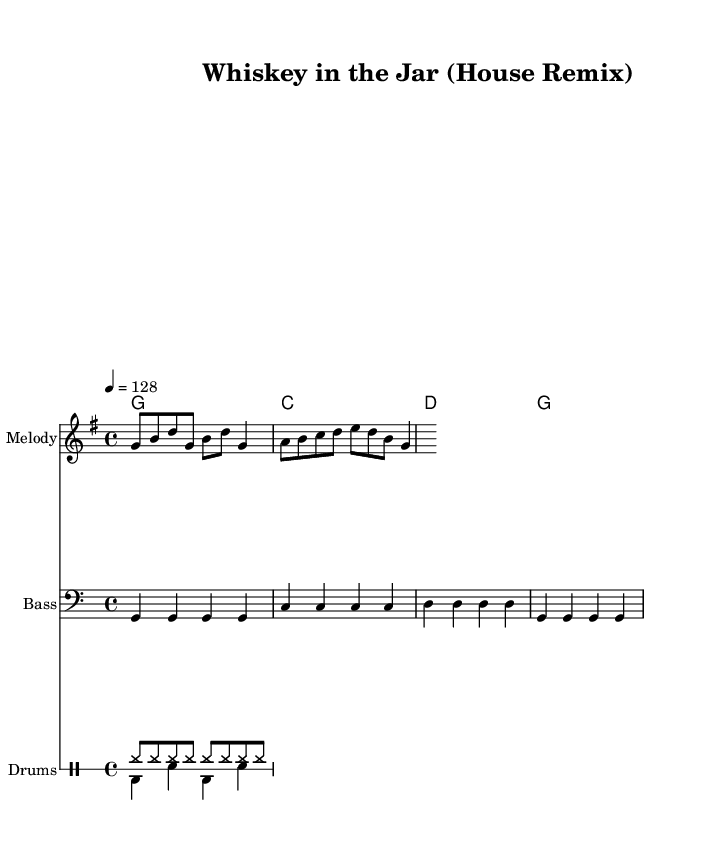What is the key signature of this music? The key signature is G major, which has one sharp (F#). This can be determined from the key signature shown at the beginning of the score.
Answer: G major What is the time signature of this music? The time signature is 4/4, indicated at the start of the score. This means there are four beats per measure, and each quarter note receives one beat.
Answer: 4/4 What is the tempo marking for this piece? The tempo marking shows a speed of 128 beats per minute, which is noted as "4 = 128." This means there are 128 quarter note beats in one minute.
Answer: 128 How many measures are in the melody section? There are four measures in the melody section, as counted by the bar lines present in the staff. Each measure is separated by a vertical line.
Answer: 4 How many total drum voices are present in this arrangement? There are two drum voices in the arrangement, as shown in the drum staff section of the score. This division is indicated by the notation used for each voice.
Answer: 2 What type of bass clef is used here? The bass clef used is the standard bass clef denoted by the lower staff, which is shown at the beginning of that part. This clef indicates the notes G to F in the fourth octave and below.
Answer: Standard What genre does this music primarily belong to? This music primarily belongs to the house genre, characterized by its upbeat tempo, rhythmic style, and incorporation of electronic elements such as drum patterns. This is indicated by the lively tempo and overall arrangement.
Answer: House 